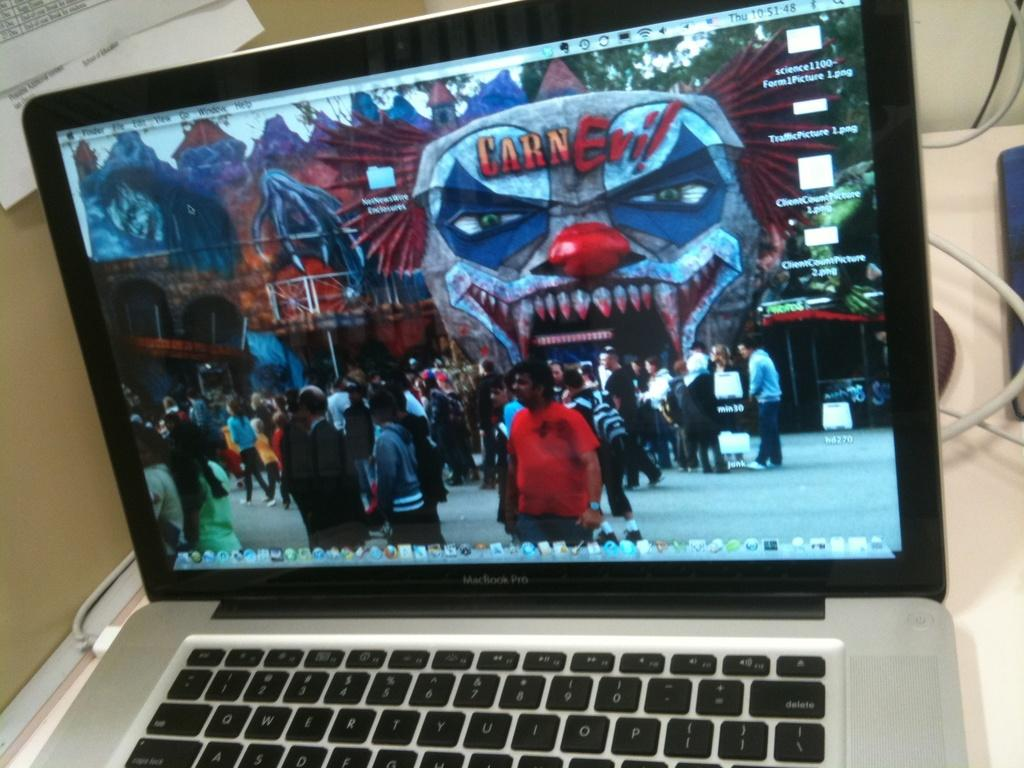<image>
Create a compact narrative representing the image presented. A laptop displays an image from a scary event called Carn-Evil. 